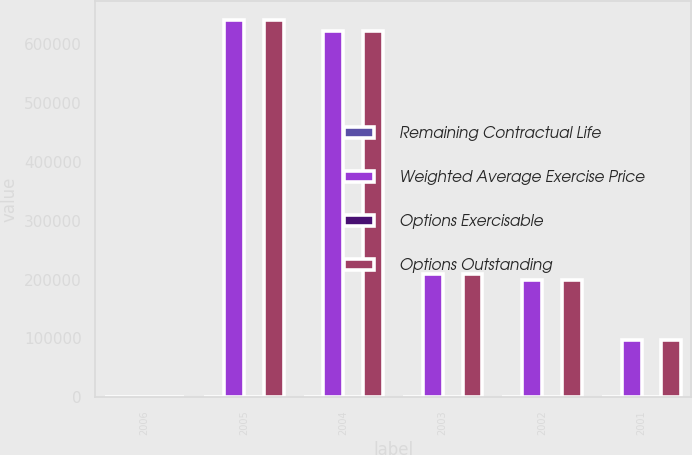Convert chart to OTSL. <chart><loc_0><loc_0><loc_500><loc_500><stacked_bar_chart><ecel><fcel>2006<fcel>2005<fcel>2004<fcel>2003<fcel>2002<fcel>2001<nl><fcel>Remaining Contractual Life<fcel>5<fcel>4<fcel>3<fcel>2<fcel>1<fcel>1<nl><fcel>Weighted Average Exercise Price<fcel>44.615<fcel>641000<fcel>621850<fcel>208600<fcel>199300<fcel>97300<nl><fcel>Options Exercisable<fcel>45.42<fcel>42.73<fcel>43.81<fcel>39.08<fcel>42.51<fcel>37.75<nl><fcel>Options Outstanding<fcel>44.615<fcel>641000<fcel>621850<fcel>208600<fcel>199300<fcel>97300<nl></chart> 